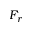<formula> <loc_0><loc_0><loc_500><loc_500>F _ { r }</formula> 